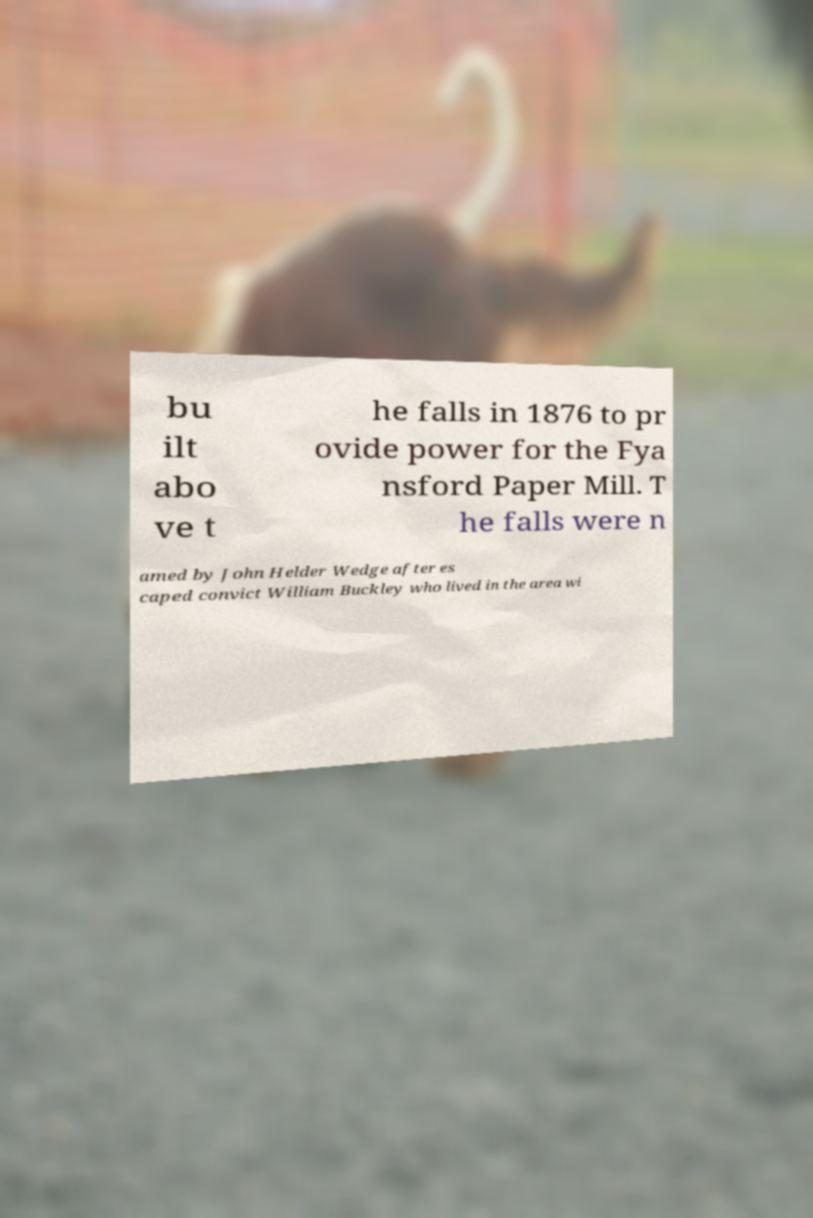Please identify and transcribe the text found in this image. bu ilt abo ve t he falls in 1876 to pr ovide power for the Fya nsford Paper Mill. T he falls were n amed by John Helder Wedge after es caped convict William Buckley who lived in the area wi 